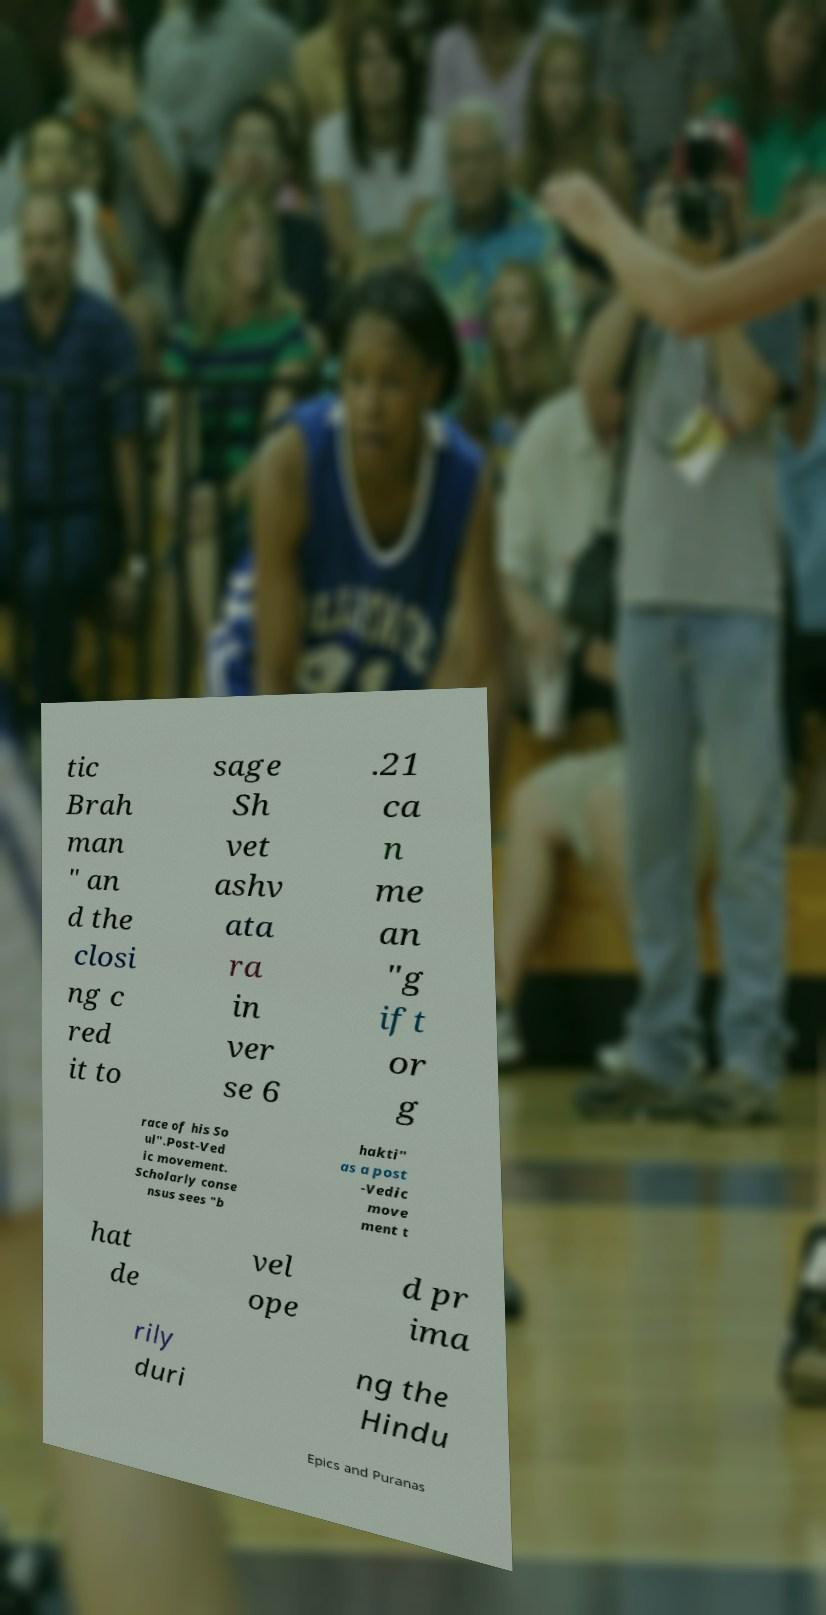Can you accurately transcribe the text from the provided image for me? tic Brah man " an d the closi ng c red it to sage Sh vet ashv ata ra in ver se 6 .21 ca n me an "g ift or g race of his So ul".Post-Ved ic movement. Scholarly conse nsus sees "b hakti" as a post -Vedic move ment t hat de vel ope d pr ima rily duri ng the Hindu Epics and Puranas 